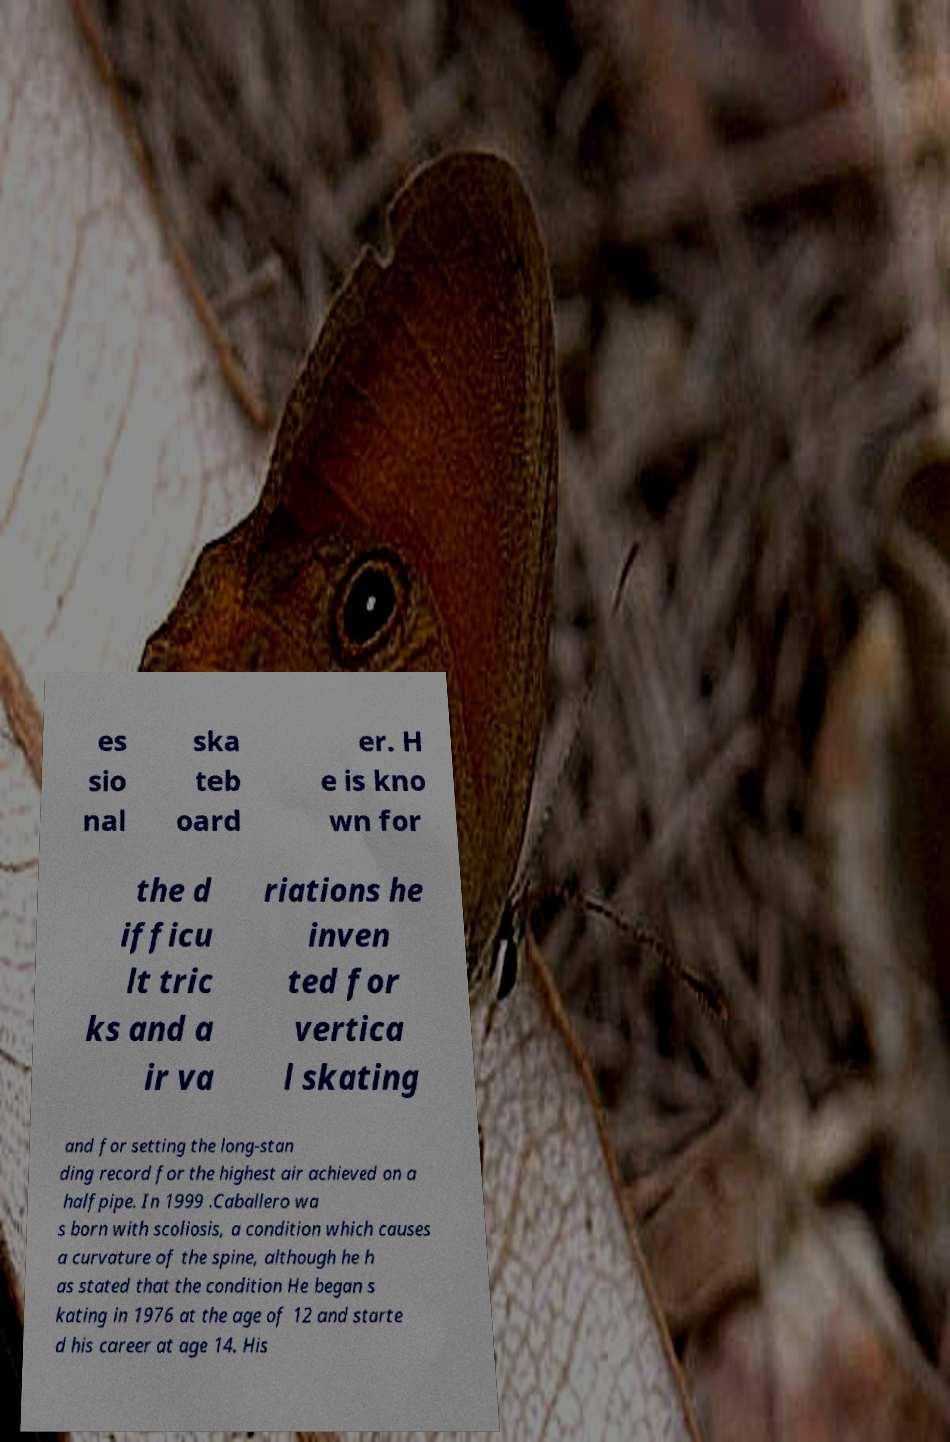Can you accurately transcribe the text from the provided image for me? es sio nal ska teb oard er. H e is kno wn for the d ifficu lt tric ks and a ir va riations he inven ted for vertica l skating and for setting the long-stan ding record for the highest air achieved on a halfpipe. In 1999 .Caballero wa s born with scoliosis, a condition which causes a curvature of the spine, although he h as stated that the condition He began s kating in 1976 at the age of 12 and starte d his career at age 14. His 